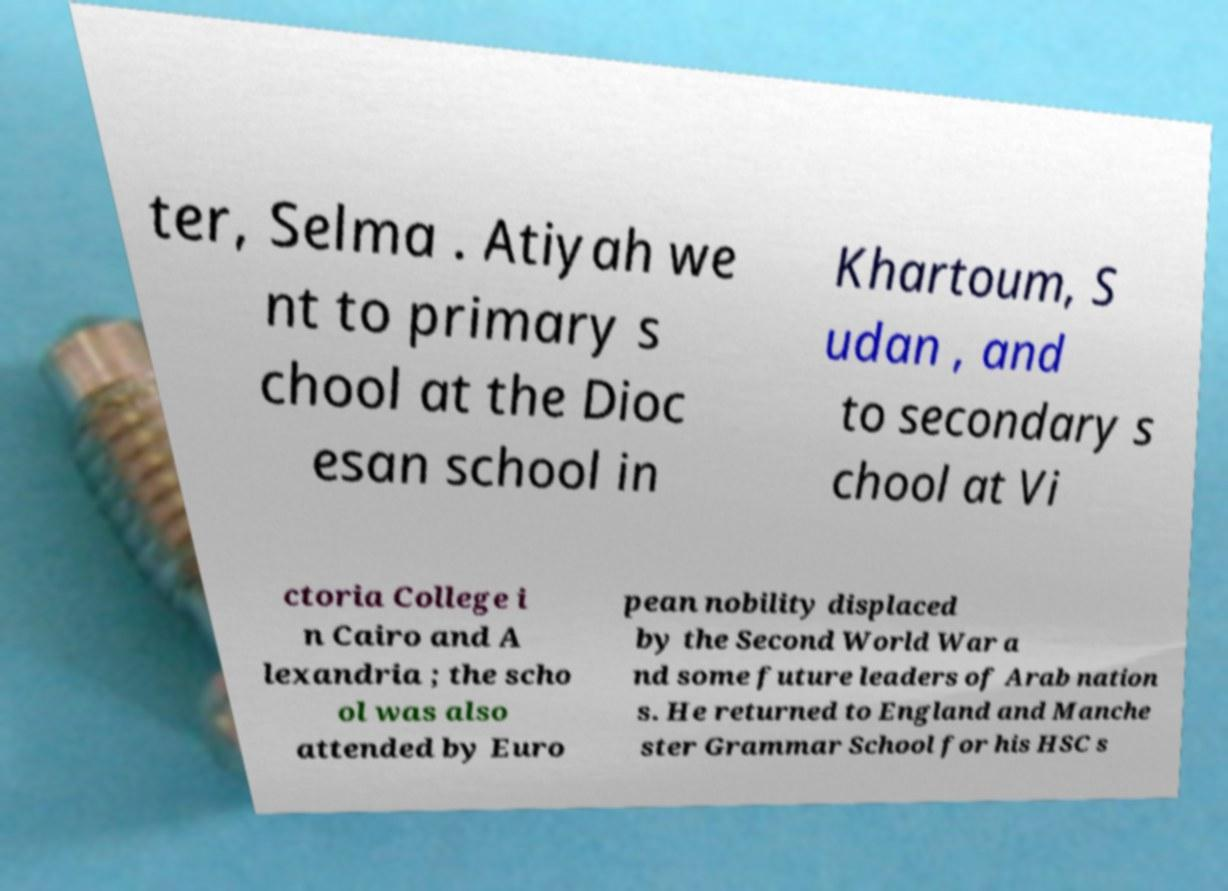Please identify and transcribe the text found in this image. ter, Selma . Atiyah we nt to primary s chool at the Dioc esan school in Khartoum, S udan , and to secondary s chool at Vi ctoria College i n Cairo and A lexandria ; the scho ol was also attended by Euro pean nobility displaced by the Second World War a nd some future leaders of Arab nation s. He returned to England and Manche ster Grammar School for his HSC s 